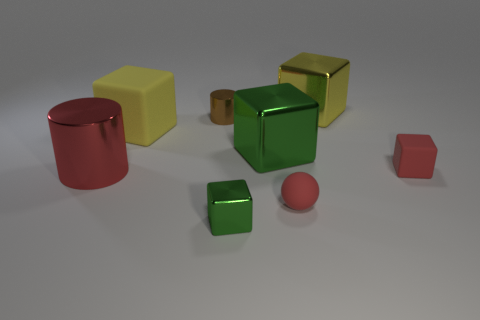How many yellow blocks must be subtracted to get 1 yellow blocks? 1 Add 2 tiny gray matte cylinders. How many objects exist? 10 Subtract all balls. How many objects are left? 7 Subtract all red rubber cylinders. Subtract all yellow matte cubes. How many objects are left? 7 Add 5 tiny matte blocks. How many tiny matte blocks are left? 6 Add 3 small red rubber balls. How many small red rubber balls exist? 4 Subtract 0 purple cubes. How many objects are left? 8 